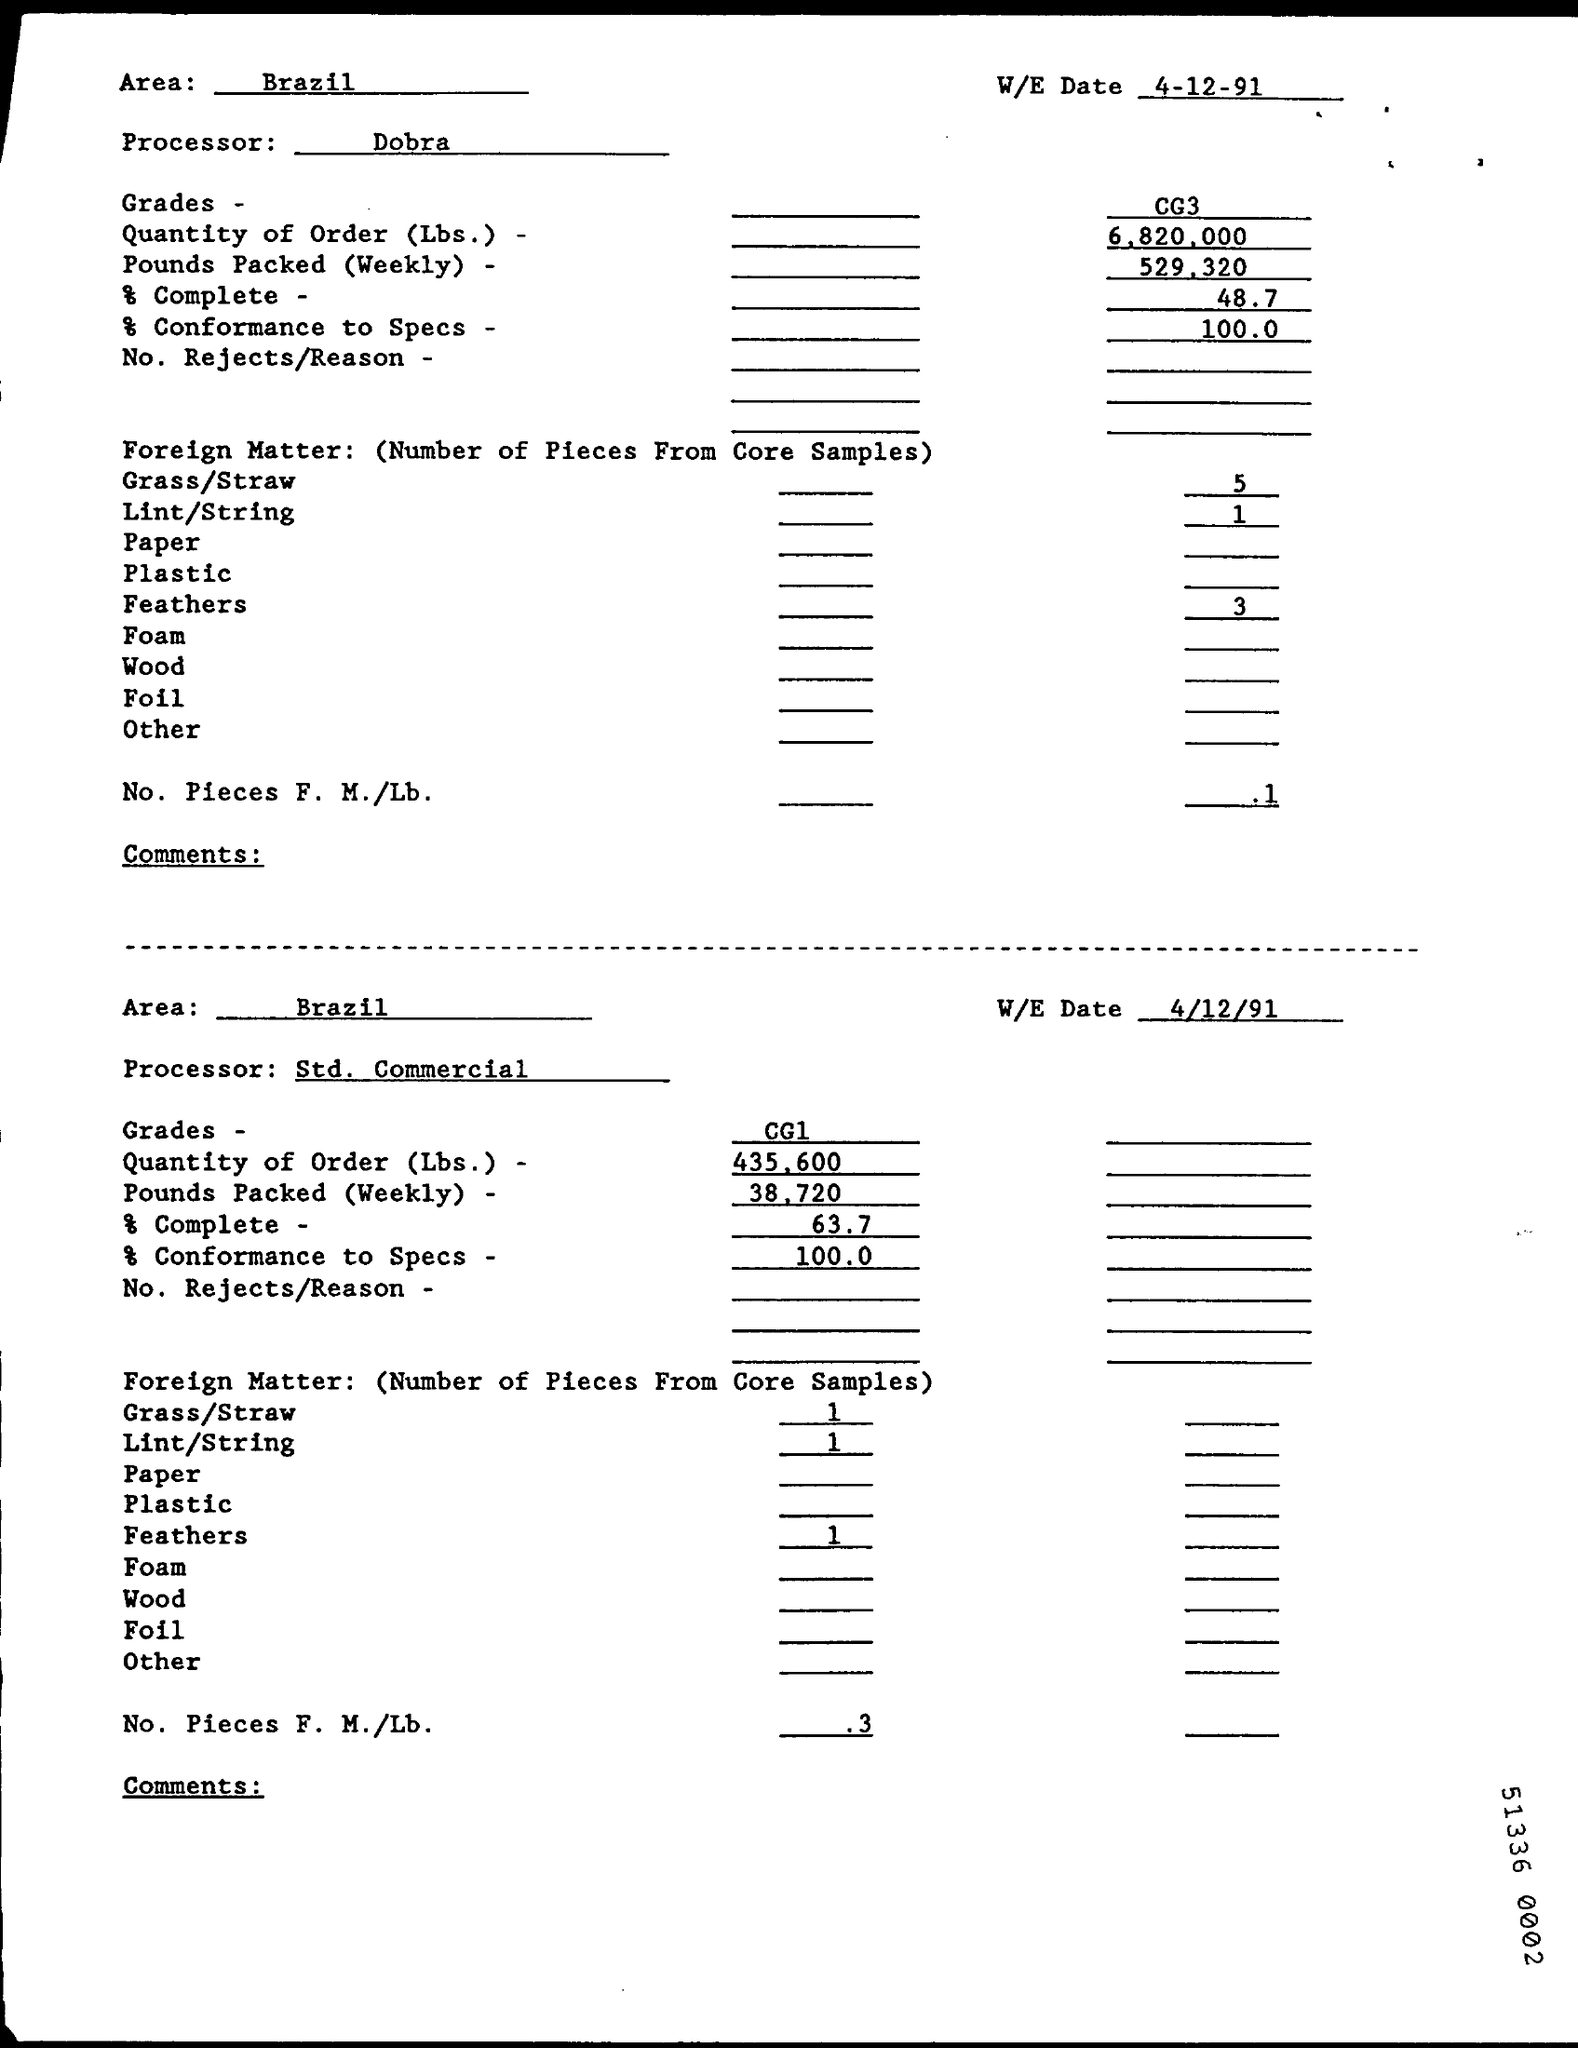Which area is mentioned?
Offer a terse response. Brazil. Who is the Processor in the first part of form?
Your response must be concise. Dobra. How many pieces of grass/straw were found from Core samples?
Ensure brevity in your answer.  5. 